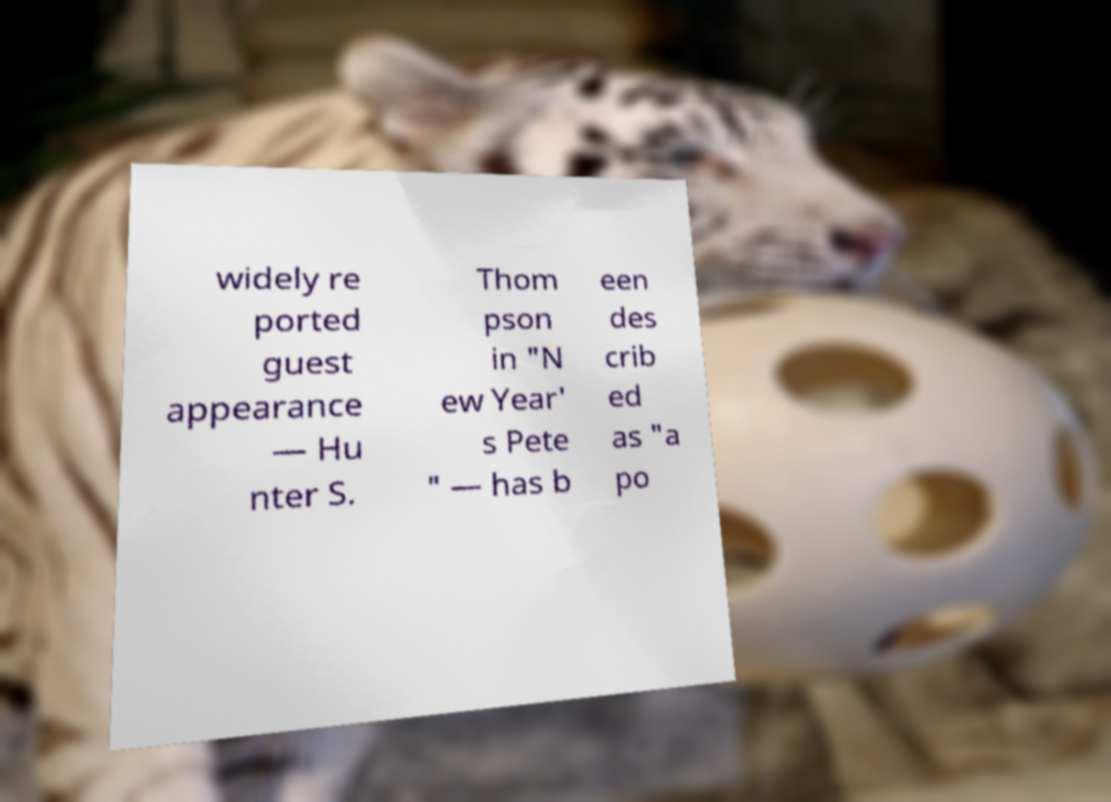Please identify and transcribe the text found in this image. widely re ported guest appearance — Hu nter S. Thom pson in "N ew Year' s Pete " — has b een des crib ed as "a po 